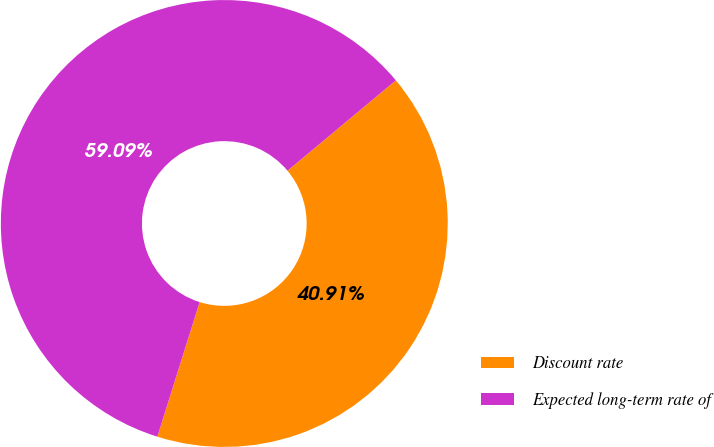<chart> <loc_0><loc_0><loc_500><loc_500><pie_chart><fcel>Discount rate<fcel>Expected long-term rate of<nl><fcel>40.91%<fcel>59.09%<nl></chart> 